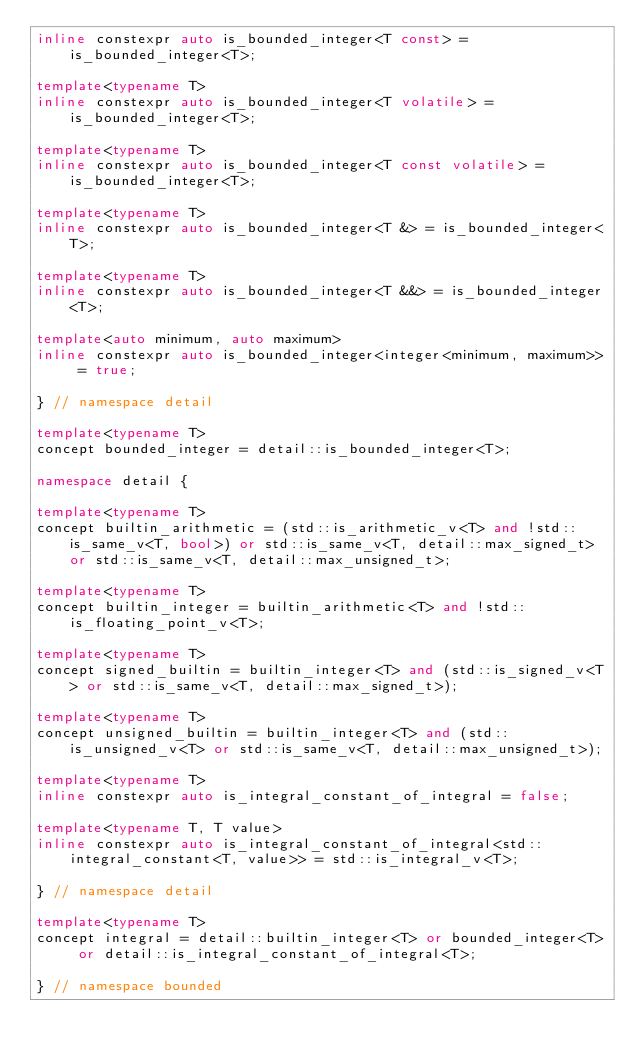<code> <loc_0><loc_0><loc_500><loc_500><_C++_>inline constexpr auto is_bounded_integer<T const> = is_bounded_integer<T>;

template<typename T>
inline constexpr auto is_bounded_integer<T volatile> = is_bounded_integer<T>;

template<typename T>
inline constexpr auto is_bounded_integer<T const volatile> = is_bounded_integer<T>;

template<typename T>
inline constexpr auto is_bounded_integer<T &> = is_bounded_integer<T>;

template<typename T>
inline constexpr auto is_bounded_integer<T &&> = is_bounded_integer<T>;

template<auto minimum, auto maximum>
inline constexpr auto is_bounded_integer<integer<minimum, maximum>> = true;

} // namespace detail

template<typename T>
concept bounded_integer = detail::is_bounded_integer<T>;

namespace detail {

template<typename T>
concept builtin_arithmetic = (std::is_arithmetic_v<T> and !std::is_same_v<T, bool>) or std::is_same_v<T, detail::max_signed_t> or std::is_same_v<T, detail::max_unsigned_t>;

template<typename T>
concept builtin_integer = builtin_arithmetic<T> and !std::is_floating_point_v<T>;

template<typename T>
concept signed_builtin = builtin_integer<T> and (std::is_signed_v<T> or std::is_same_v<T, detail::max_signed_t>);

template<typename T>
concept unsigned_builtin = builtin_integer<T> and (std::is_unsigned_v<T> or std::is_same_v<T, detail::max_unsigned_t>);

template<typename T>
inline constexpr auto is_integral_constant_of_integral = false;

template<typename T, T value>
inline constexpr auto is_integral_constant_of_integral<std::integral_constant<T, value>> = std::is_integral_v<T>;

} // namespace detail

template<typename T>
concept integral = detail::builtin_integer<T> or bounded_integer<T> or detail::is_integral_constant_of_integral<T>;

} // namespace bounded
</code> 